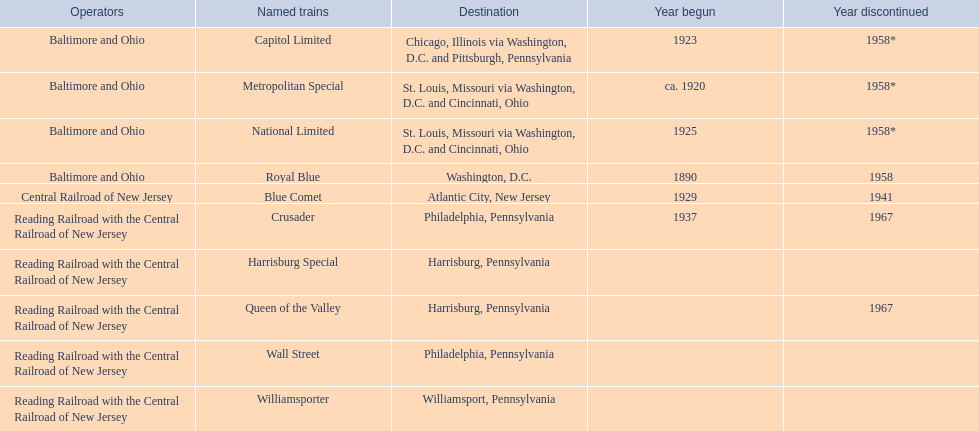What are the endpoints for the central railroad of new jersey terminal? Chicago, Illinois via Washington, D.C. and Pittsburgh, Pennsylvania, St. Louis, Missouri via Washington, D.C. and Cincinnati, Ohio, St. Louis, Missouri via Washington, D.C. and Cincinnati, Ohio, Washington, D.C., Atlantic City, New Jersey, Philadelphia, Pennsylvania, Harrisburg, Pennsylvania, Harrisburg, Pennsylvania, Philadelphia, Pennsylvania, Williamsport, Pennsylvania. Which of these endpoints is considered the most important? Chicago, Illinois via Washington, D.C. and Pittsburgh, Pennsylvania. 